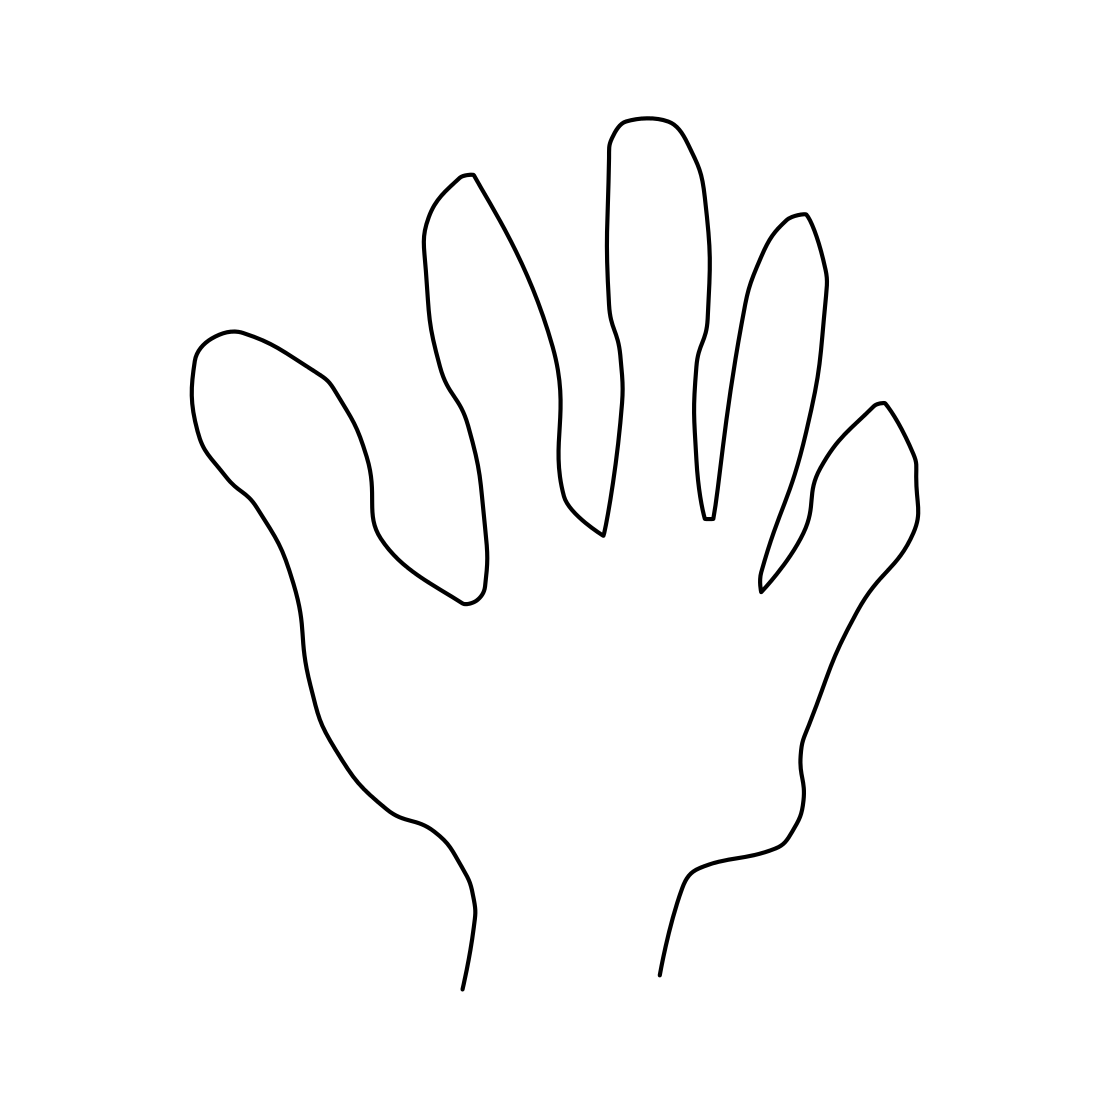Is this a frog in the image? No 